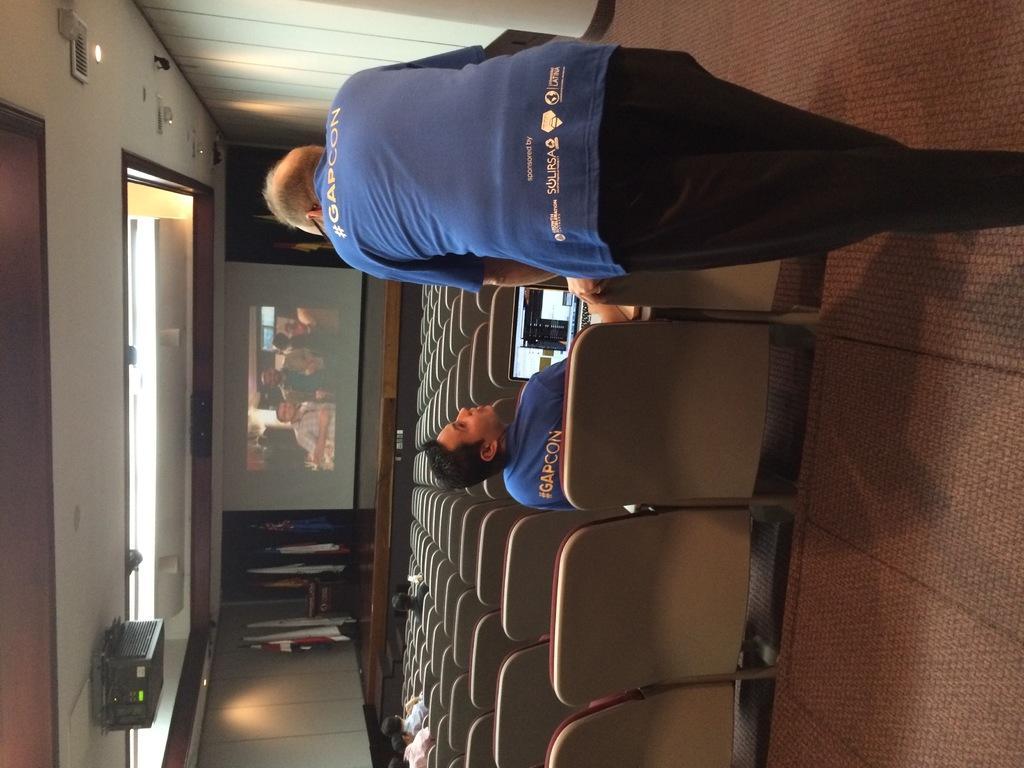Please provide a concise description of this image. In this rotated image there are many seats. There are a few people sitting on the seats. In the foreground there is a man sitting. In front of him there is a laptop. Beside him there is another man standing. In the center there is a projector screen on the dais. Beside the screen there are flags. To the left there is a ceiling. There are lights and a projector to the ceiling. 